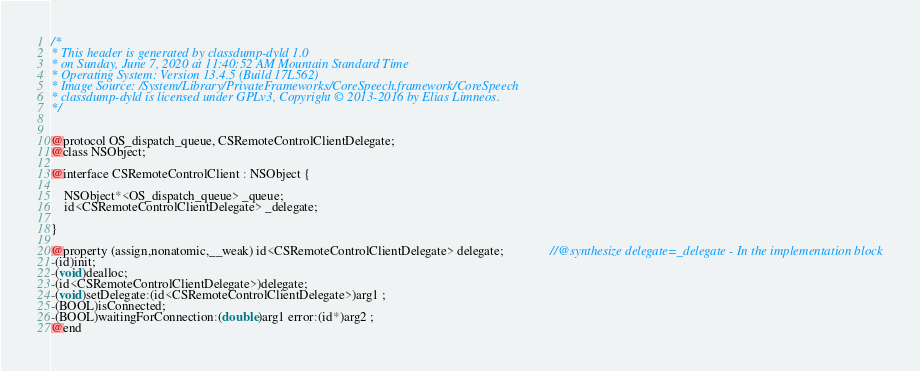<code> <loc_0><loc_0><loc_500><loc_500><_C_>/*
* This header is generated by classdump-dyld 1.0
* on Sunday, June 7, 2020 at 11:40:52 AM Mountain Standard Time
* Operating System: Version 13.4.5 (Build 17L562)
* Image Source: /System/Library/PrivateFrameworks/CoreSpeech.framework/CoreSpeech
* classdump-dyld is licensed under GPLv3, Copyright © 2013-2016 by Elias Limneos.
*/


@protocol OS_dispatch_queue, CSRemoteControlClientDelegate;
@class NSObject;

@interface CSRemoteControlClient : NSObject {

	NSObject*<OS_dispatch_queue> _queue;
	id<CSRemoteControlClientDelegate> _delegate;

}

@property (assign,nonatomic,__weak) id<CSRemoteControlClientDelegate> delegate;              //@synthesize delegate=_delegate - In the implementation block
-(id)init;
-(void)dealloc;
-(id<CSRemoteControlClientDelegate>)delegate;
-(void)setDelegate:(id<CSRemoteControlClientDelegate>)arg1 ;
-(BOOL)isConnected;
-(BOOL)waitingForConnection:(double)arg1 error:(id*)arg2 ;
@end

</code> 